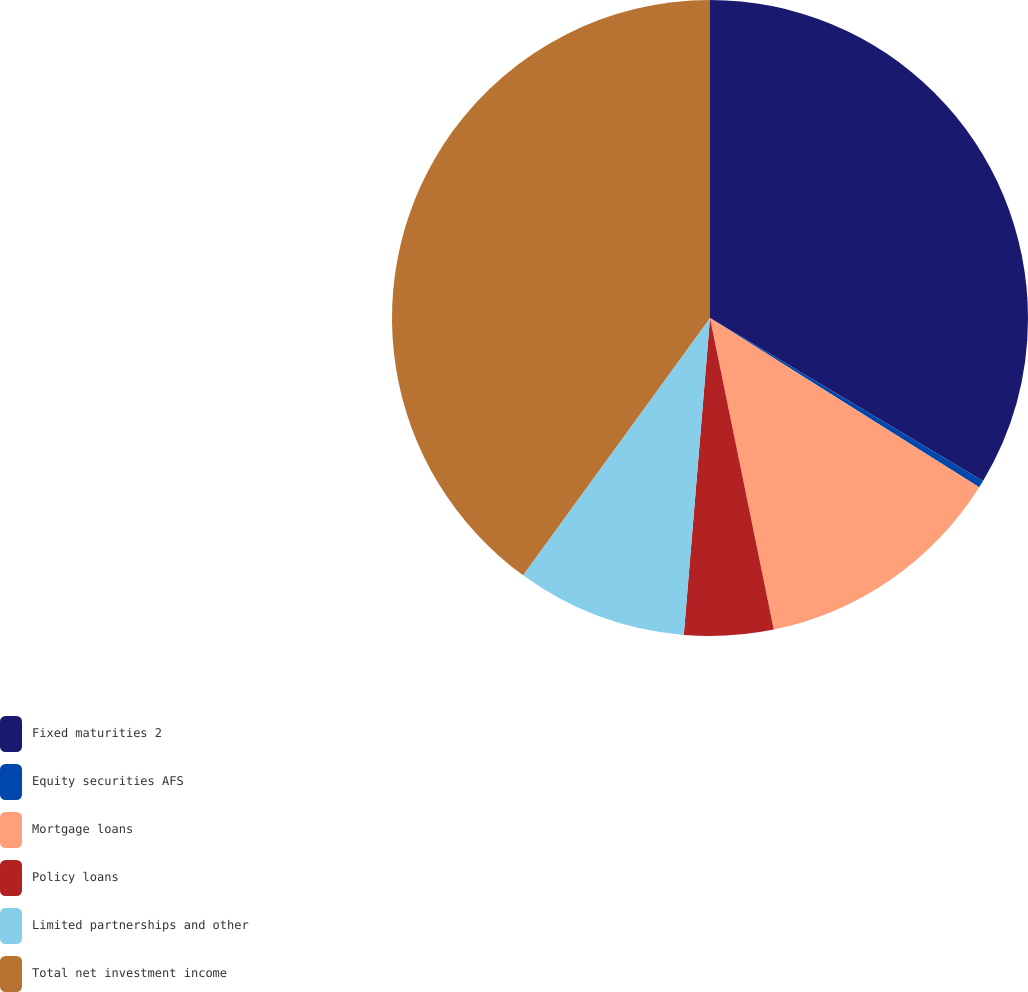Convert chart. <chart><loc_0><loc_0><loc_500><loc_500><pie_chart><fcel>Fixed maturities 2<fcel>Equity securities AFS<fcel>Mortgage loans<fcel>Policy loans<fcel>Limited partnerships and other<fcel>Total net investment income<nl><fcel>33.57%<fcel>0.37%<fcel>12.85%<fcel>4.53%<fcel>8.69%<fcel>40.0%<nl></chart> 